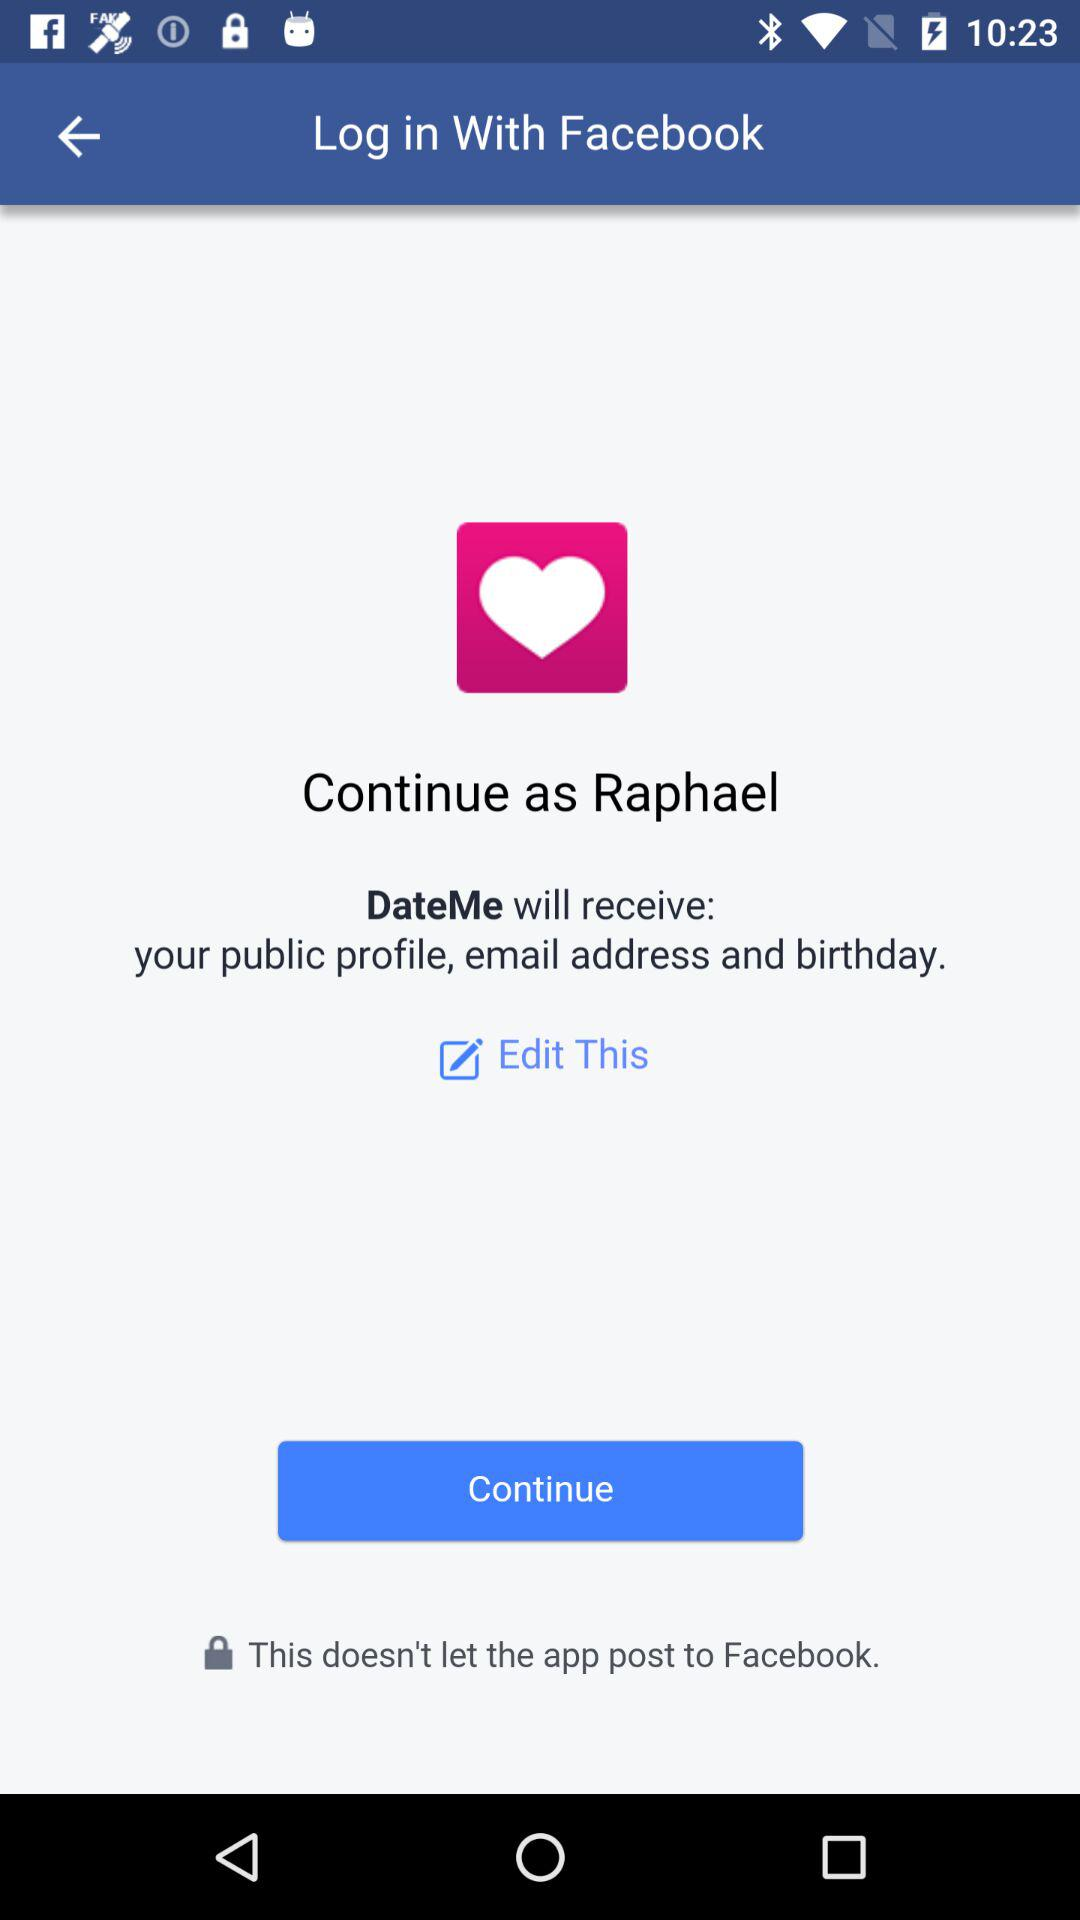What is the login name? The login name is Raphael. 